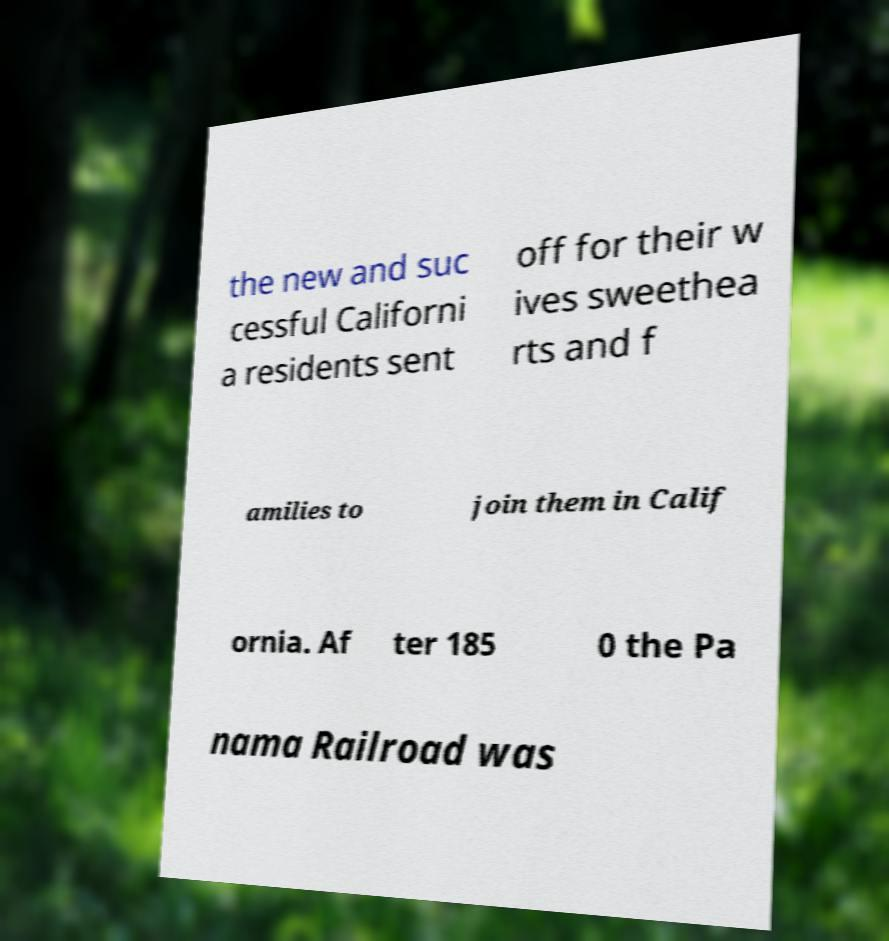What messages or text are displayed in this image? I need them in a readable, typed format. the new and suc cessful Californi a residents sent off for their w ives sweethea rts and f amilies to join them in Calif ornia. Af ter 185 0 the Pa nama Railroad was 